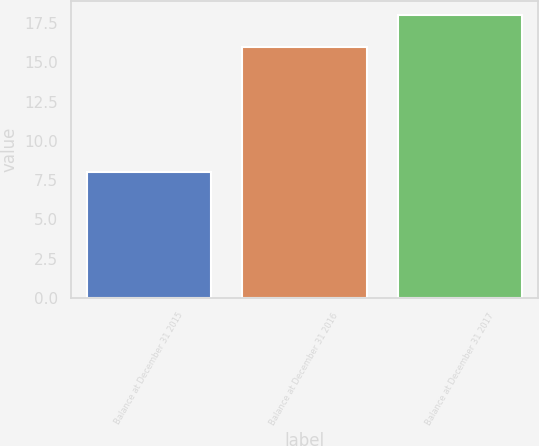Convert chart. <chart><loc_0><loc_0><loc_500><loc_500><bar_chart><fcel>Balance at December 31 2015<fcel>Balance at December 31 2016<fcel>Balance at December 31 2017<nl><fcel>8<fcel>16<fcel>18<nl></chart> 